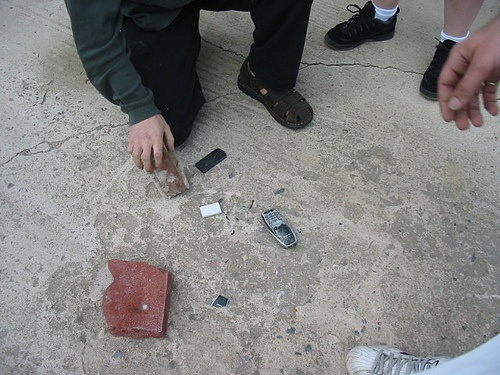Describe the objects in this image and their specific colors. I can see people in gray, black, darkgray, and purple tones, people in gray, brown, maroon, and black tones, people in gray and black tones, cell phone in gray, darkgray, and darkblue tones, and cell phone in gray, black, purple, and darkblue tones in this image. 